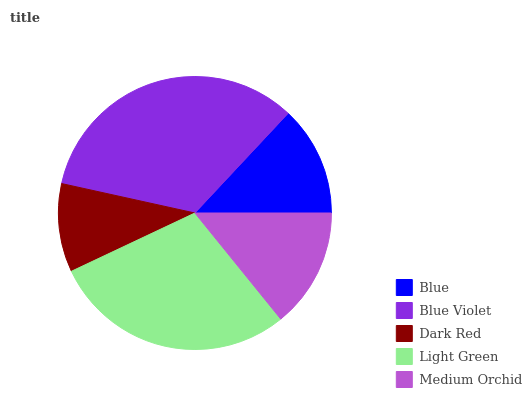Is Dark Red the minimum?
Answer yes or no. Yes. Is Blue Violet the maximum?
Answer yes or no. Yes. Is Blue Violet the minimum?
Answer yes or no. No. Is Dark Red the maximum?
Answer yes or no. No. Is Blue Violet greater than Dark Red?
Answer yes or no. Yes. Is Dark Red less than Blue Violet?
Answer yes or no. Yes. Is Dark Red greater than Blue Violet?
Answer yes or no. No. Is Blue Violet less than Dark Red?
Answer yes or no. No. Is Medium Orchid the high median?
Answer yes or no. Yes. Is Medium Orchid the low median?
Answer yes or no. Yes. Is Light Green the high median?
Answer yes or no. No. Is Light Green the low median?
Answer yes or no. No. 